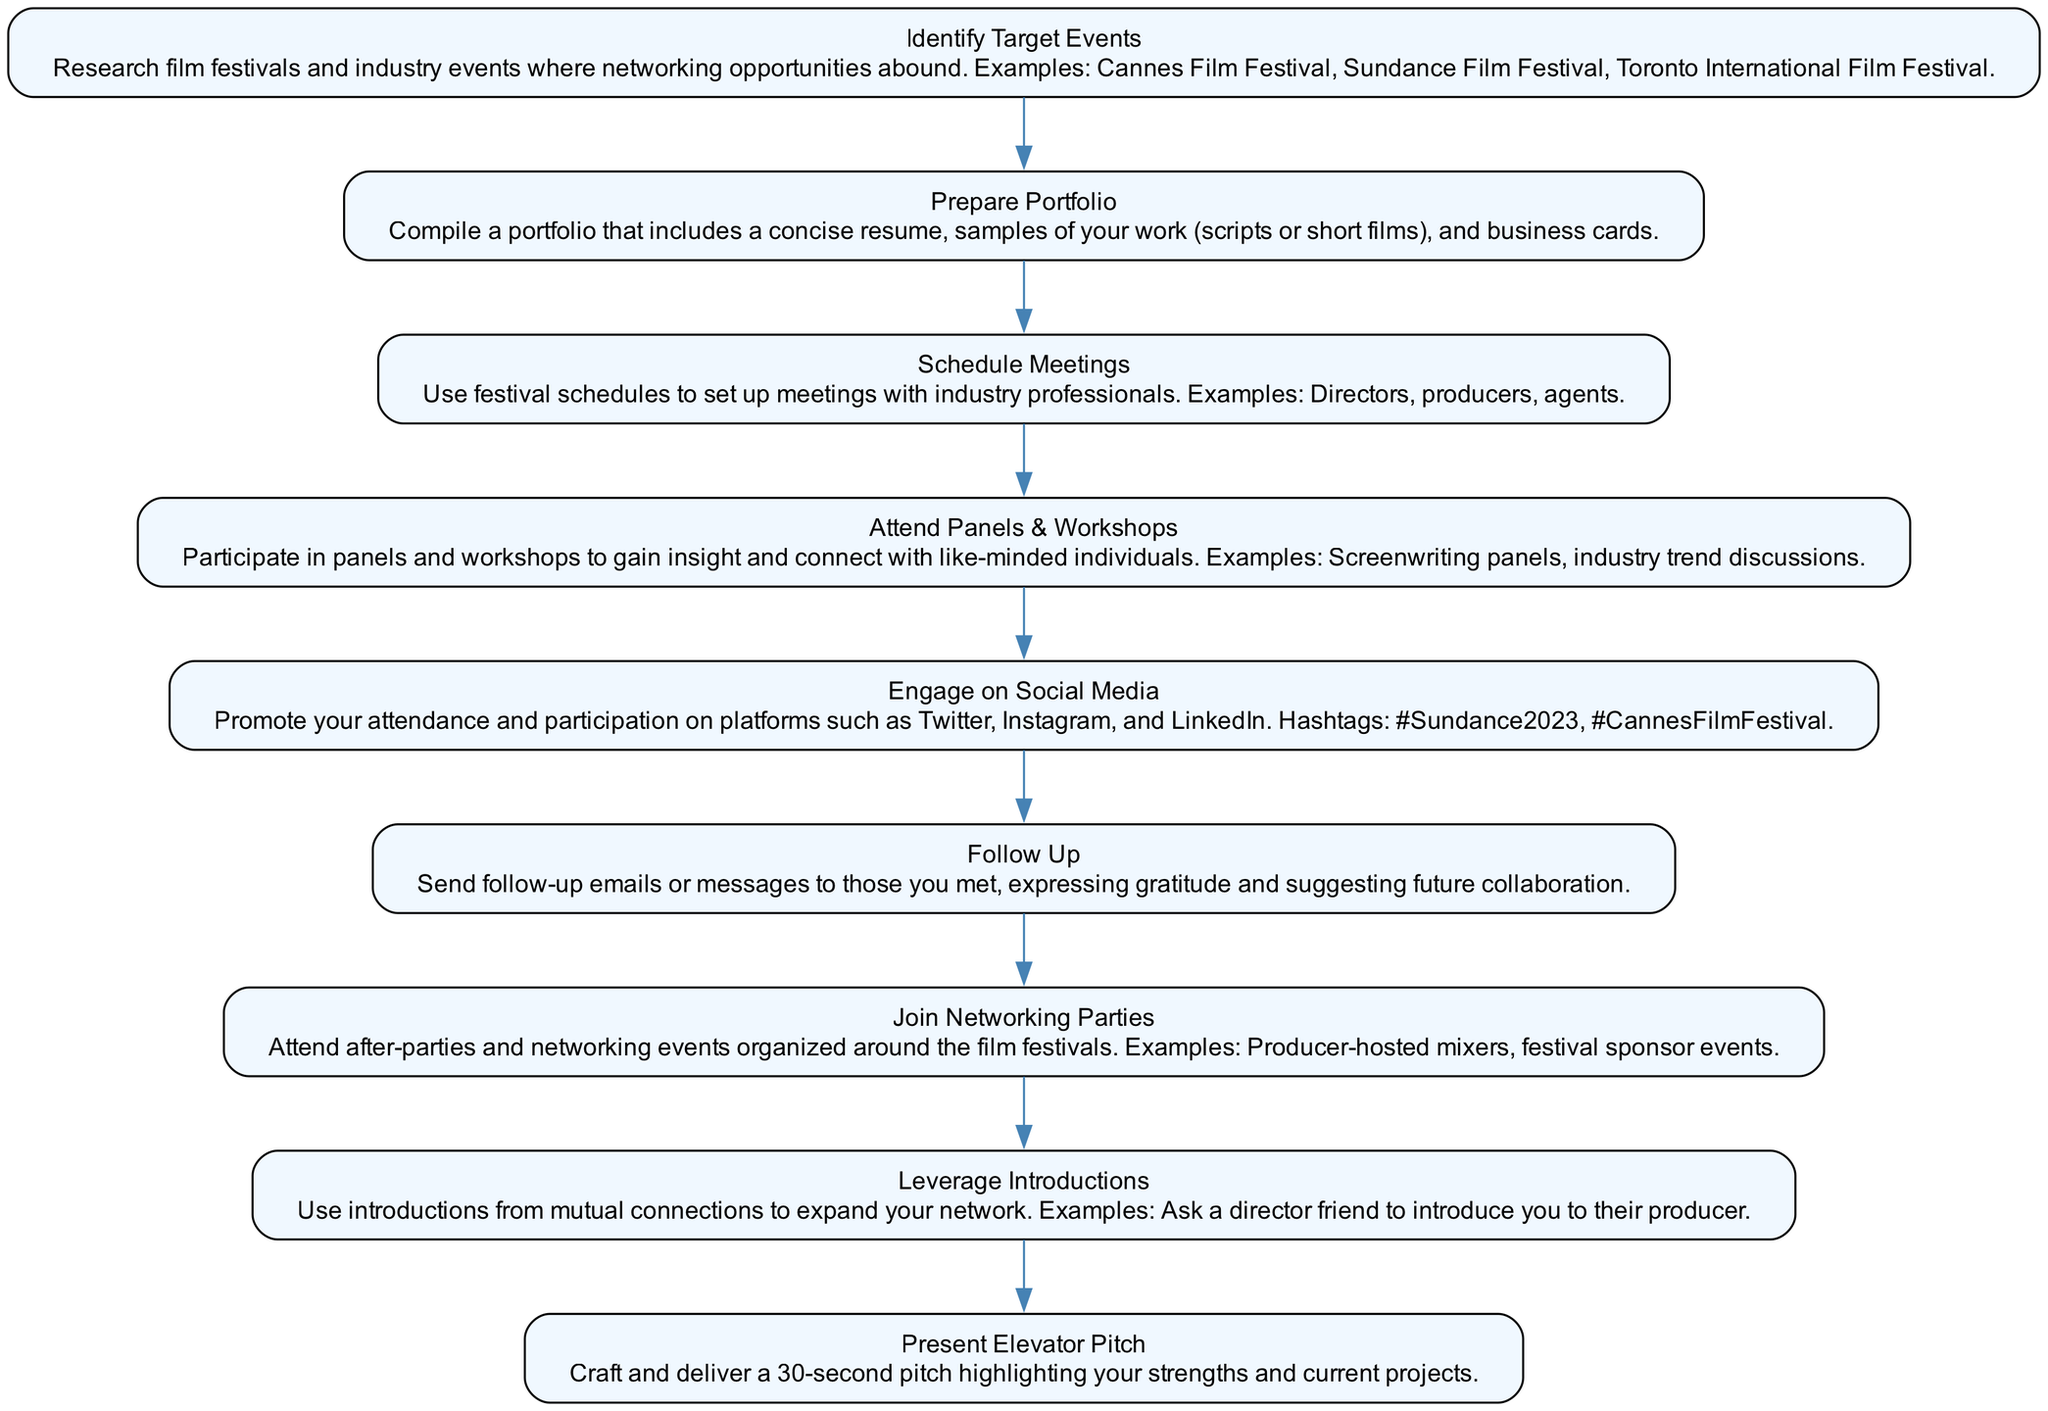What is the first step in the networking strategy? The first step is labeled "Identify Target Events." It is the first element listed in the flowchart, indicating that it is the starting point for the networking strategy.
Answer: Identify Target Events How many nodes are represented in the diagram? By counting each of the listed elements in the flowchart, there are a total of nine distinct nodes present.
Answer: 9 Which step directly follows "Prepare Portfolio"? The step that follows "Prepare Portfolio" is "Schedule Meetings." This can be determined by following the flow of the diagram from one node to the next.
Answer: Schedule Meetings What is the last step in the networking strategy? The last step is "Follow Up," which is the final node in the sequence. This indicates that after networking occurs, follow-up is the concluding action suggested.
Answer: Follow Up How many times does "Attend Panels & Workshops" appear in the flowchart? The phrase "Attend Panels & Workshops" appears only once, as indicated by its unique node in the diagram.
Answer: 1 Which steps involve engaging with people directly? The steps that involve direct engagement include "Schedule Meetings," "Attend Panels & Workshops," "Join Networking Parties," and "Leverage Introductions." These steps all emphasize connecting with individuals in various contexts.
Answer: Schedule Meetings, Attend Panels & Workshops, Join Networking Parties, Leverage Introductions What is the relationship between "Engage on Social Media" and "Follow Up"? "Engage on Social Media" precedes "Follow Up" in the flowchart, indicating a sequence where promoting participation on social media occurs before sending follow-up messages.
Answer: Sequence What are some examples given for networking opportunities at events? Examples provided in the "Identify Target Events" node include Cannes Film Festival, Sundance Film Festival, and Toronto International Film Festival, all indicating significant opportunities for networking within the film industry.
Answer: Cannes Film Festival, Sundance Film Festival, Toronto International Film Festival What does the term "Elevator Pitch" refer to in the context of the diagram? The term "Elevator Pitch" refers to a crafted and delivered 30-second pitch that highlights the individual's strengths and current projects. This is captured under "Present Elevator Pitch."
Answer: 30-second pitch 